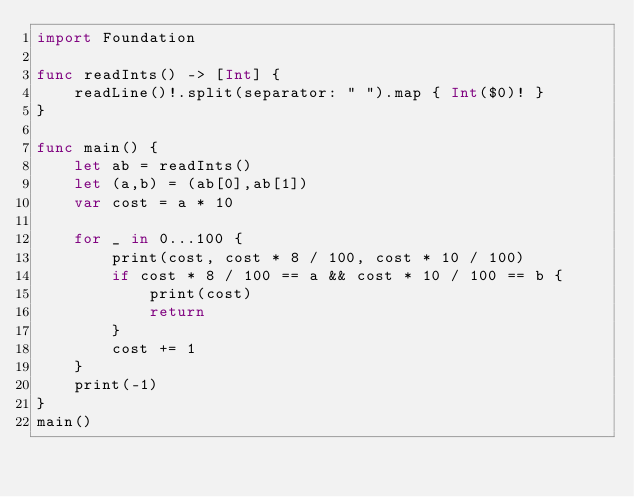<code> <loc_0><loc_0><loc_500><loc_500><_Swift_>import Foundation

func readInts() -> [Int] {
    readLine()!.split(separator: " ").map { Int($0)! }
}

func main() {
    let ab = readInts()
    let (a,b) = (ab[0],ab[1])
    var cost = a * 10
    
    for _ in 0...100 {
        print(cost, cost * 8 / 100, cost * 10 / 100)
        if cost * 8 / 100 == a && cost * 10 / 100 == b {
            print(cost)
            return
        }
        cost += 1
    }
    print(-1)
}
main()
</code> 